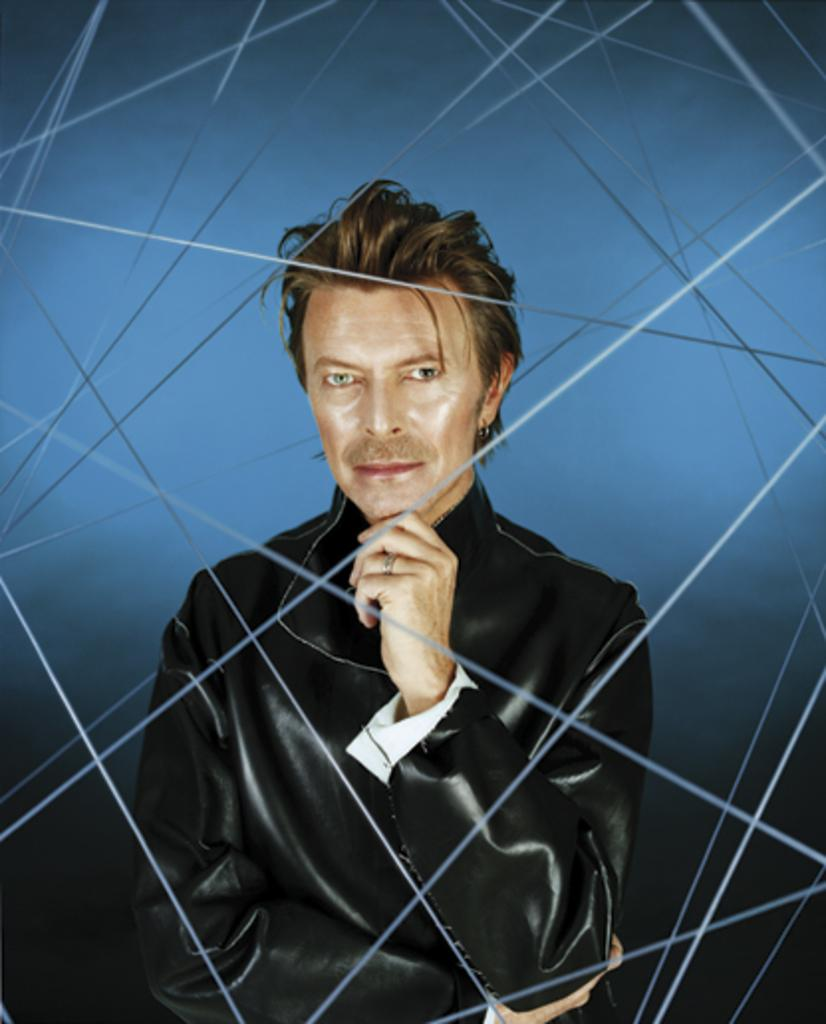What is the main subject of the animated image in the picture? The main subject of the animated image is a man standing. What can be observed about the man's attire? The man is wearing clothes. Are there any accessories visible on the man? Yes, the man has a finger ring and an earring. Can you describe the background of the image? The background of the image is blackish blue with visible lines. What type of cord is connected to the animated man in the image? There is no cord connected to the animated man in the image. Can you provide an example of a van that might be related to the image? There is no van present in the image, so it is not possible to provide an example related to the image. 